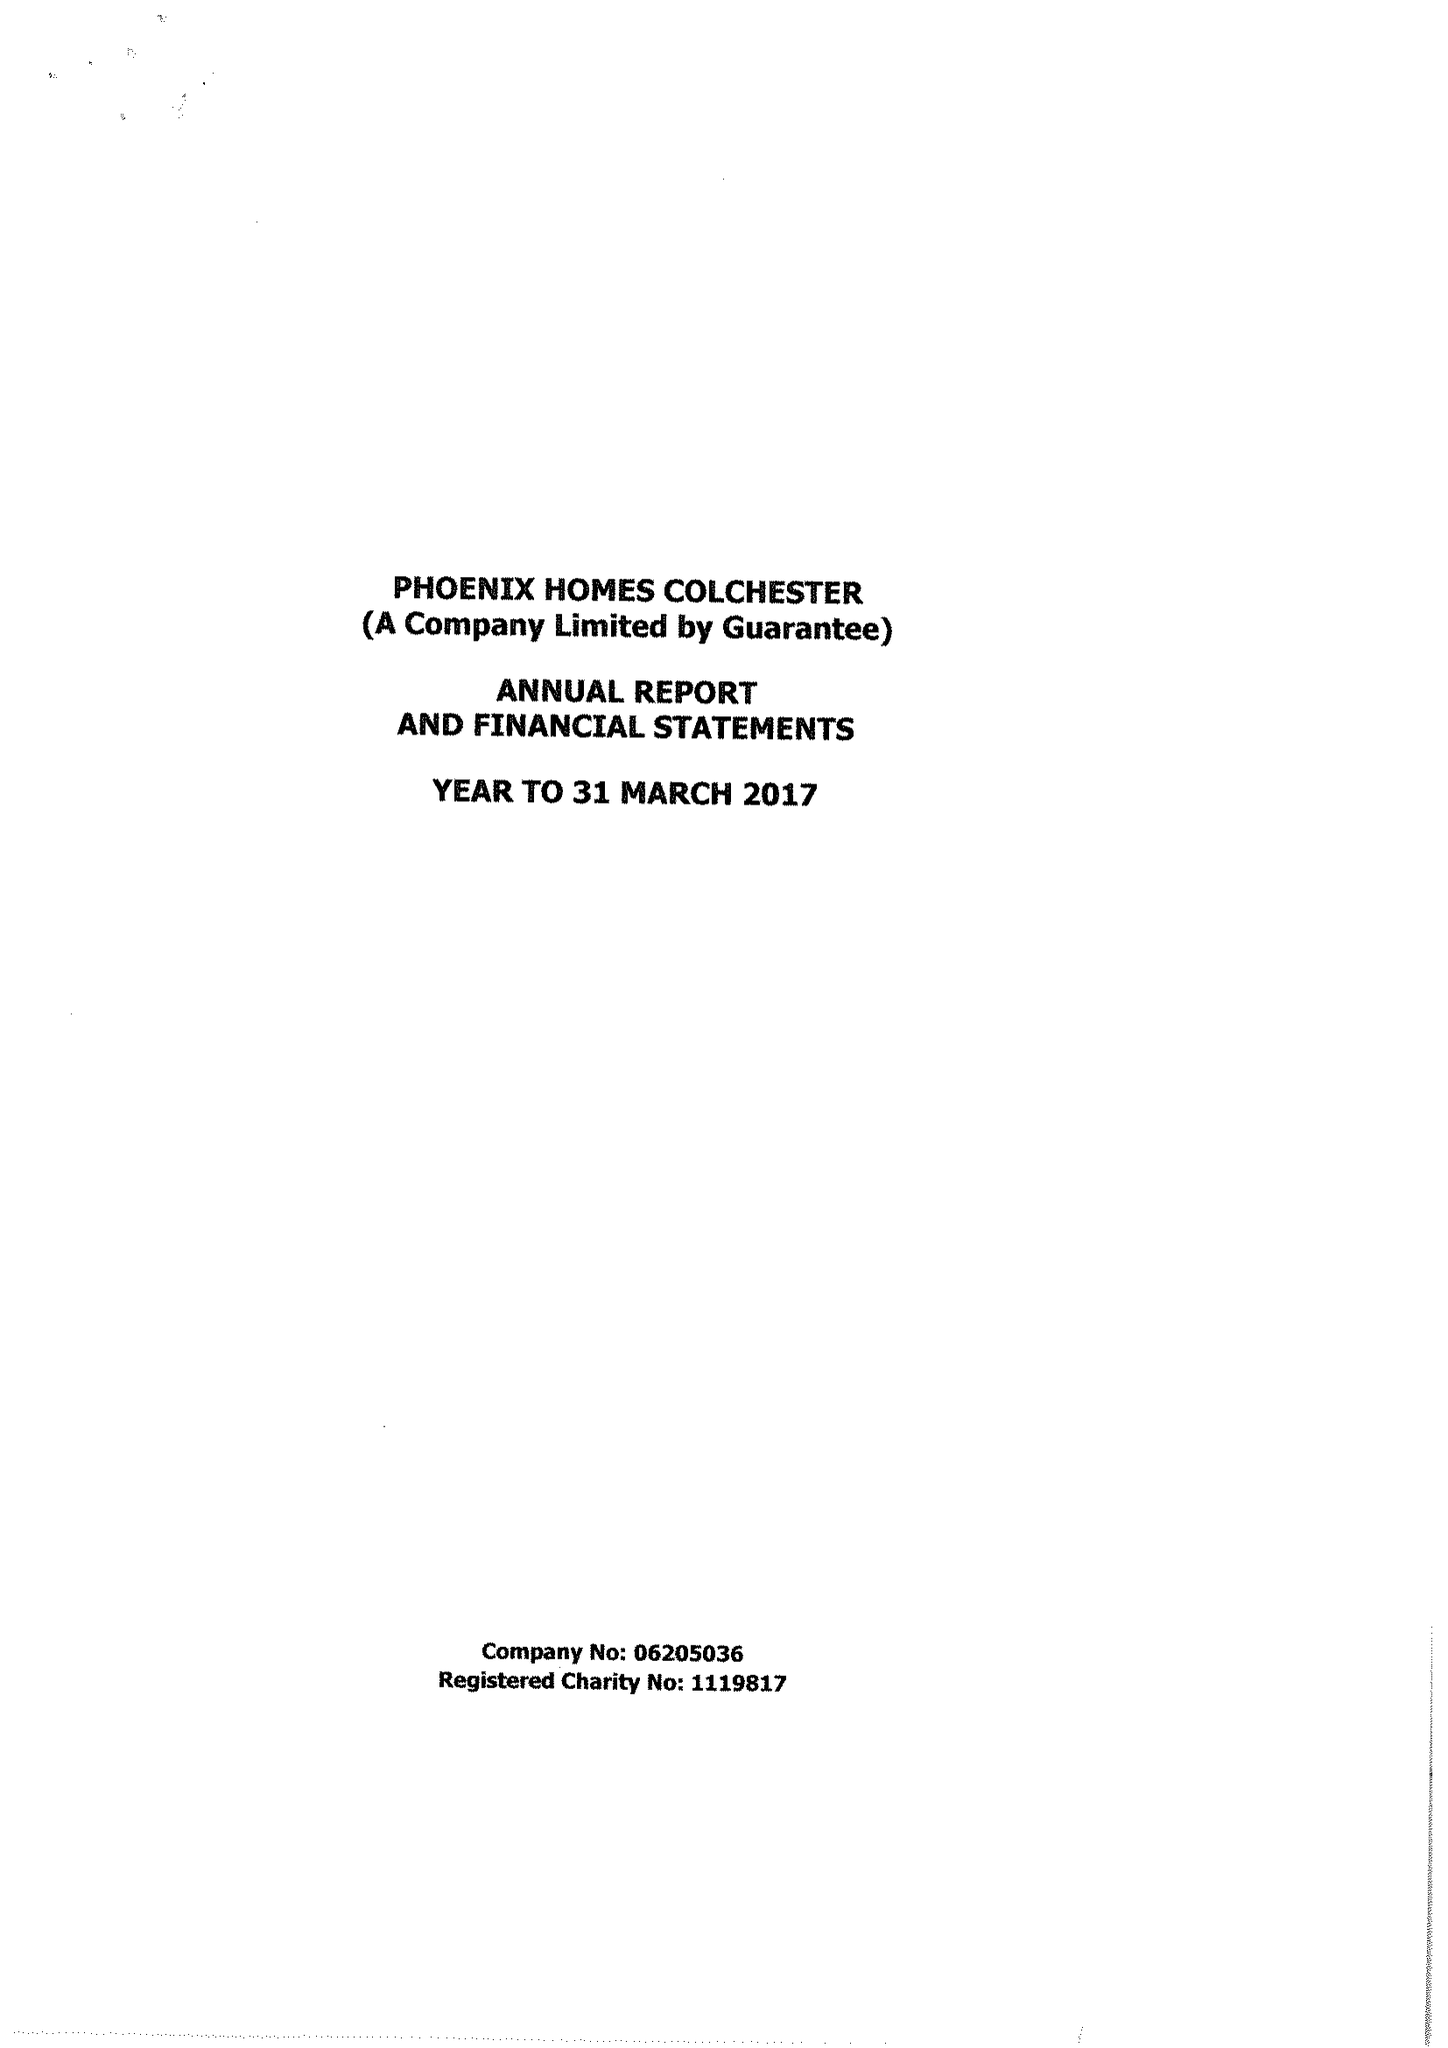What is the value for the income_annually_in_british_pounds?
Answer the question using a single word or phrase. 368408.00 